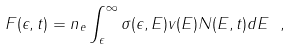Convert formula to latex. <formula><loc_0><loc_0><loc_500><loc_500>F ( \epsilon , t ) = n _ { e } \int _ { \epsilon } ^ { \infty } \sigma ( \epsilon , E ) v ( E ) N ( E , t ) d E \ ,</formula> 